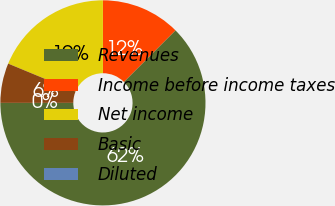<chart> <loc_0><loc_0><loc_500><loc_500><pie_chart><fcel>Revenues<fcel>Income before income taxes<fcel>Net income<fcel>Basic<fcel>Diluted<nl><fcel>62.5%<fcel>12.5%<fcel>18.75%<fcel>6.25%<fcel>0.0%<nl></chart> 